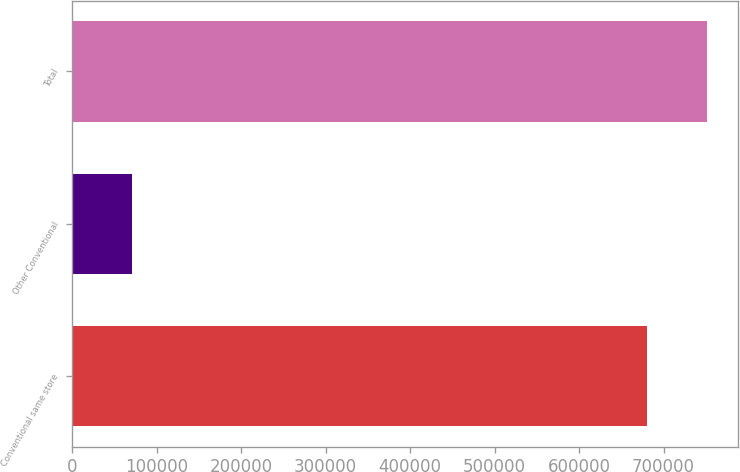<chart> <loc_0><loc_0><loc_500><loc_500><bar_chart><fcel>Conventional same store<fcel>Other Conventional<fcel>Total<nl><fcel>680311<fcel>70812<fcel>751123<nl></chart> 